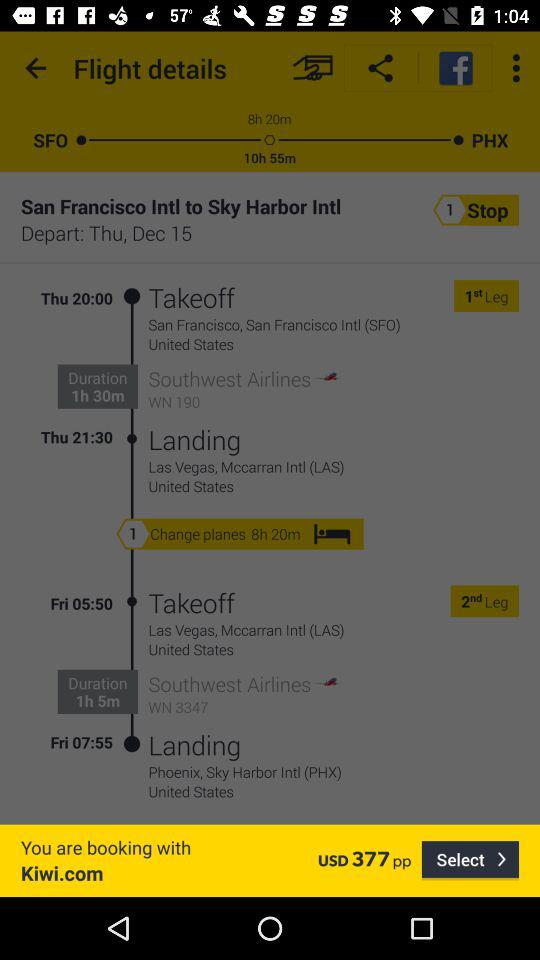What is the time duration of Southwest Airlines WN 190? The time duration of Southwest Airlines WN 190 is 1 hour 30 minutes. 